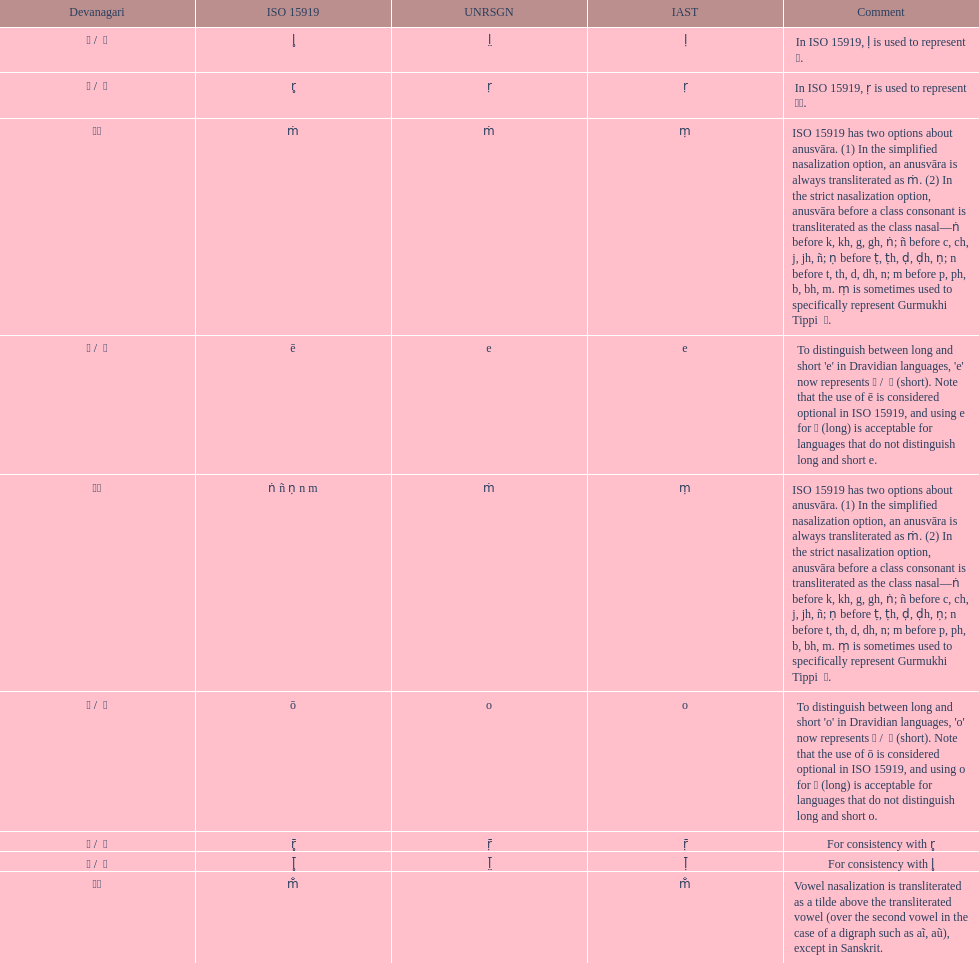What is the total number of translations? 8. 